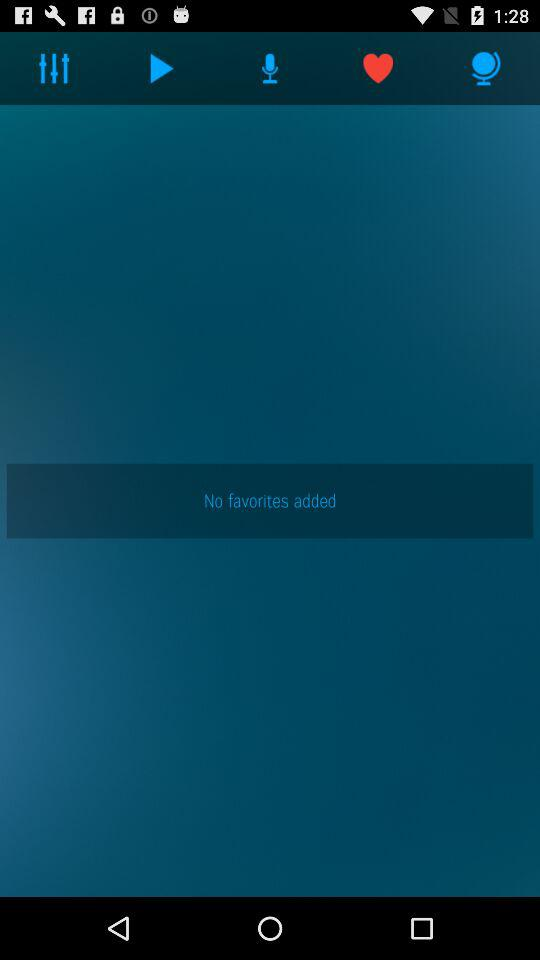Is there any favorite item added? There is no favorite item added. 